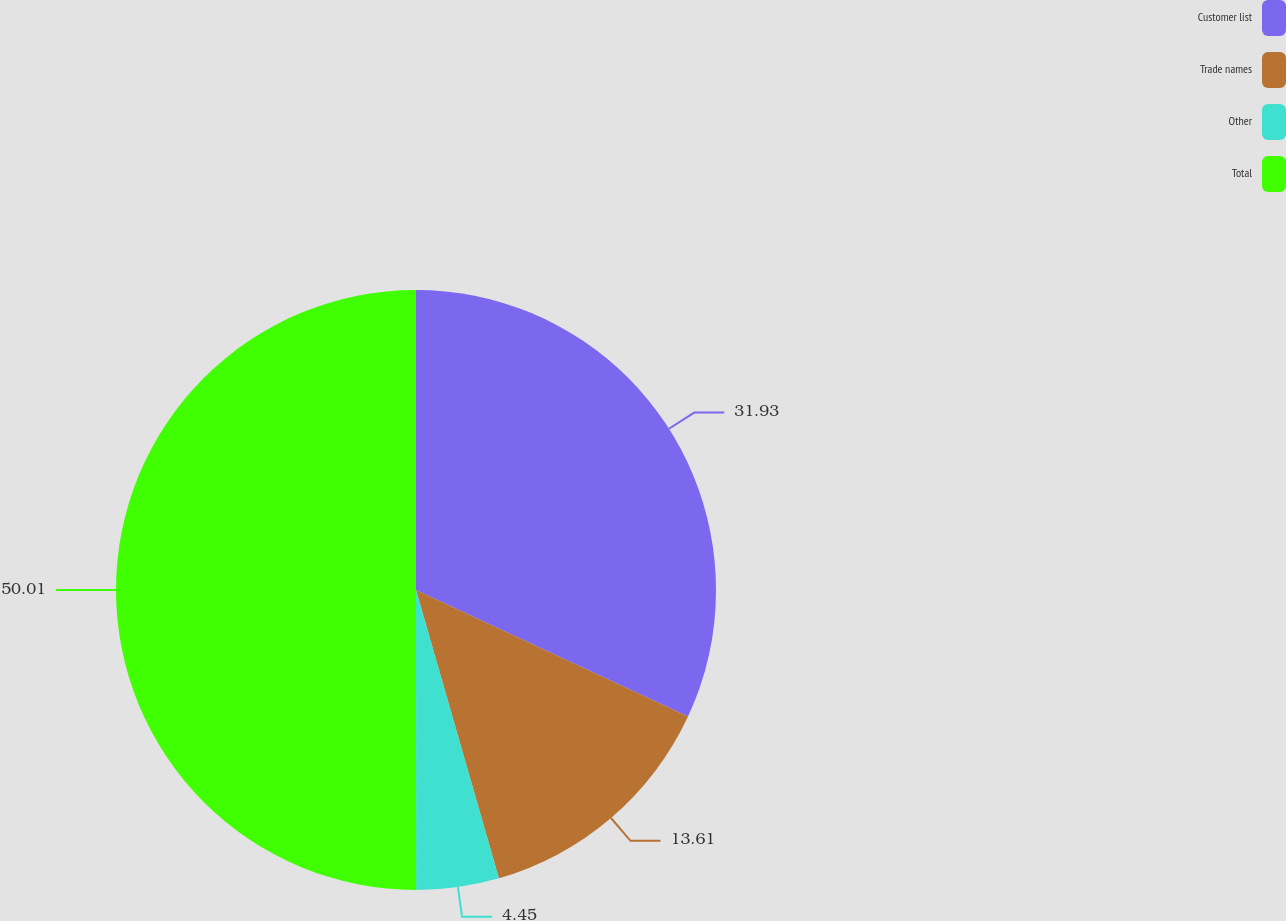Convert chart to OTSL. <chart><loc_0><loc_0><loc_500><loc_500><pie_chart><fcel>Customer list<fcel>Trade names<fcel>Other<fcel>Total<nl><fcel>31.93%<fcel>13.61%<fcel>4.45%<fcel>50.0%<nl></chart> 